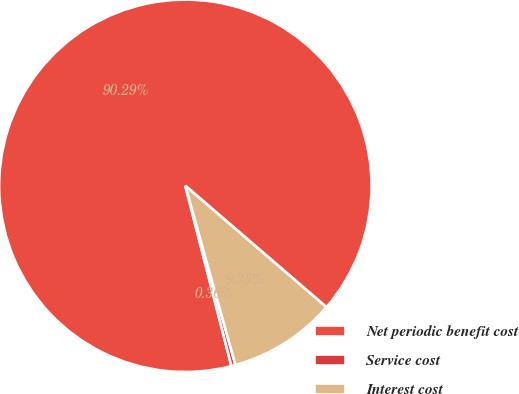Convert chart to OTSL. <chart><loc_0><loc_0><loc_500><loc_500><pie_chart><fcel>Net periodic benefit cost<fcel>Service cost<fcel>Interest cost<nl><fcel>90.29%<fcel>0.36%<fcel>9.35%<nl></chart> 